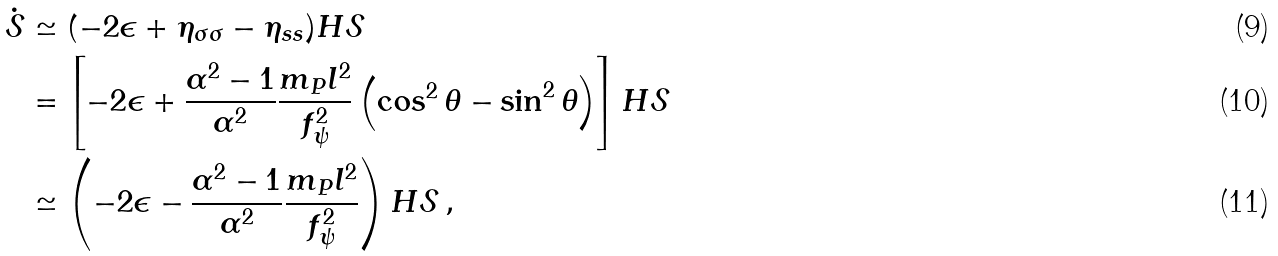<formula> <loc_0><loc_0><loc_500><loc_500>\dot { \mathcal { S } } & \simeq ( - 2 \epsilon + \eta _ { \sigma \sigma } - \eta _ { s s } ) H \mathcal { S } \\ & = \left [ - 2 \epsilon + \frac { \alpha ^ { 2 } - 1 } { \alpha ^ { 2 } } \frac { m _ { P } l ^ { 2 } } { f _ { \psi } ^ { 2 } } \left ( \cos ^ { 2 } \theta - \sin ^ { 2 } \theta \right ) \right ] H \mathcal { S } \\ & \simeq \left ( - 2 \epsilon - \frac { \alpha ^ { 2 } - 1 } { \alpha ^ { 2 } } \frac { m _ { P } l ^ { 2 } } { f _ { \psi } ^ { 2 } } \right ) H \mathcal { S } \, ,</formula> 